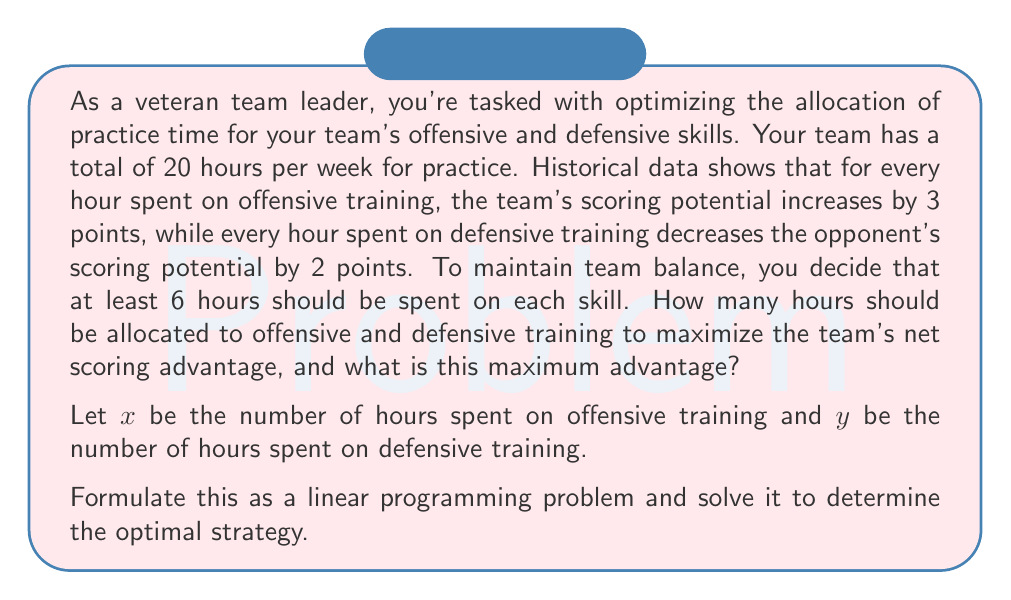Help me with this question. To solve this linear programming problem, we'll follow these steps:

1. Define the objective function
2. Identify the constraints
3. Graph the feasible region
4. Find the optimal solution

Step 1: Define the objective function

The objective is to maximize the net scoring advantage. This can be expressed as:
$$ Z = 3x + 2y $$
Where $3x$ represents the increase in scoring potential from offensive training, and $2y$ represents the decrease in opponent's scoring potential from defensive training.

Step 2: Identify the constraints

We have the following constraints:
1. Total practice time: $x + y = 20$
2. Minimum time for each skill: $x \geq 6$ and $y \geq 6$
3. Non-negativity: $x \geq 0$ and $y \geq 0$ (implicitly satisfied by constraint 2)

Step 3: Graph the feasible region

We can graph these constraints:

[asy]
unitsize(1cm);
defaultpen(fontsize(10pt));

// Draw axes
draw((-1,0)--(21,0), arrow=Arrow(TeXHead));
draw((0,-1)--(0,21), arrow=Arrow(TeXHead));

// Label axes
label("$x$", (21,0), E);
label("$y$", (0,21), N);

// Draw constraints
draw((0,20)--(20,0), blue);
draw((6,0)--(6,14), red);
draw((0,6)--(14,6), red);

// Shade feasible region
fill((6,6)--(6,14)--(14,6)--cycle, lightgray);

// Label points
label("(6,14)", (6,14), NE);
label("(14,6)", (14,6), SE);

// Label lines
label("$x + y = 20$", (10,11), NW, blue);
label("$x = 6$", (6,10), E, red);
label("$y = 6$", (10,6), N, red);
[/asy]

The feasible region is the shaded triangle.

Step 4: Find the optimal solution

In linear programming, the optimal solution always occurs at a corner point of the feasible region. The corner points are (6,14), (14,6), and (6,6). We evaluate the objective function at each point:

At (6,14): $Z = 3(6) + 2(14) = 46$
At (14,6): $Z = 3(14) + 2(6) = 54$
At (6,6): $Z = 3(6) + 2(6) = 30$

The maximum value occurs at the point (14,6), which means 14 hours should be allocated to offensive training and 6 hours to defensive training.
Answer: The optimal strategy is to allocate 14 hours to offensive training and 6 hours to defensive training. This will result in a maximum net scoring advantage of 54 points. 